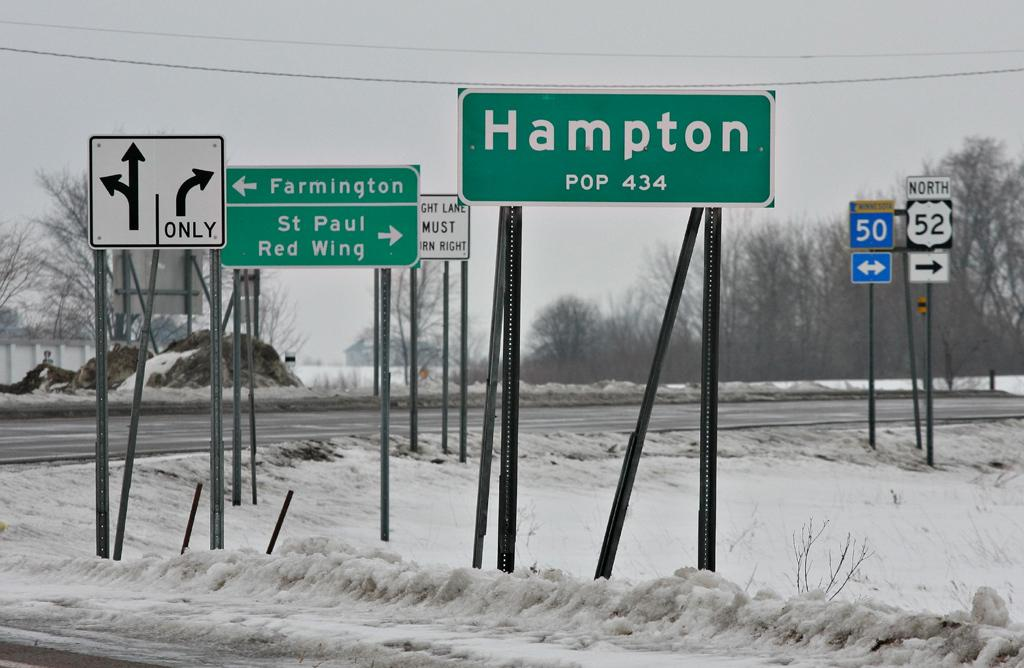What type of vegetation can be seen in the image? There are trees in the image. What type of signs are present in the image? There are name boards and sign boards on poles in the image. What is the weather like in the image? There is snow visible in the image, and the sky is cloudy. What type of structure is present in the image? There is a building in the image. What type of popcorn can be seen hanging from the branches of the trees in the image? There is no popcorn present in the image; it features trees, name boards, sign boards, snow, a cloudy sky, and a building. How many clocks are visible on the building in the image? There is no mention of clocks on the building in the image; it only states that there is a building present. 